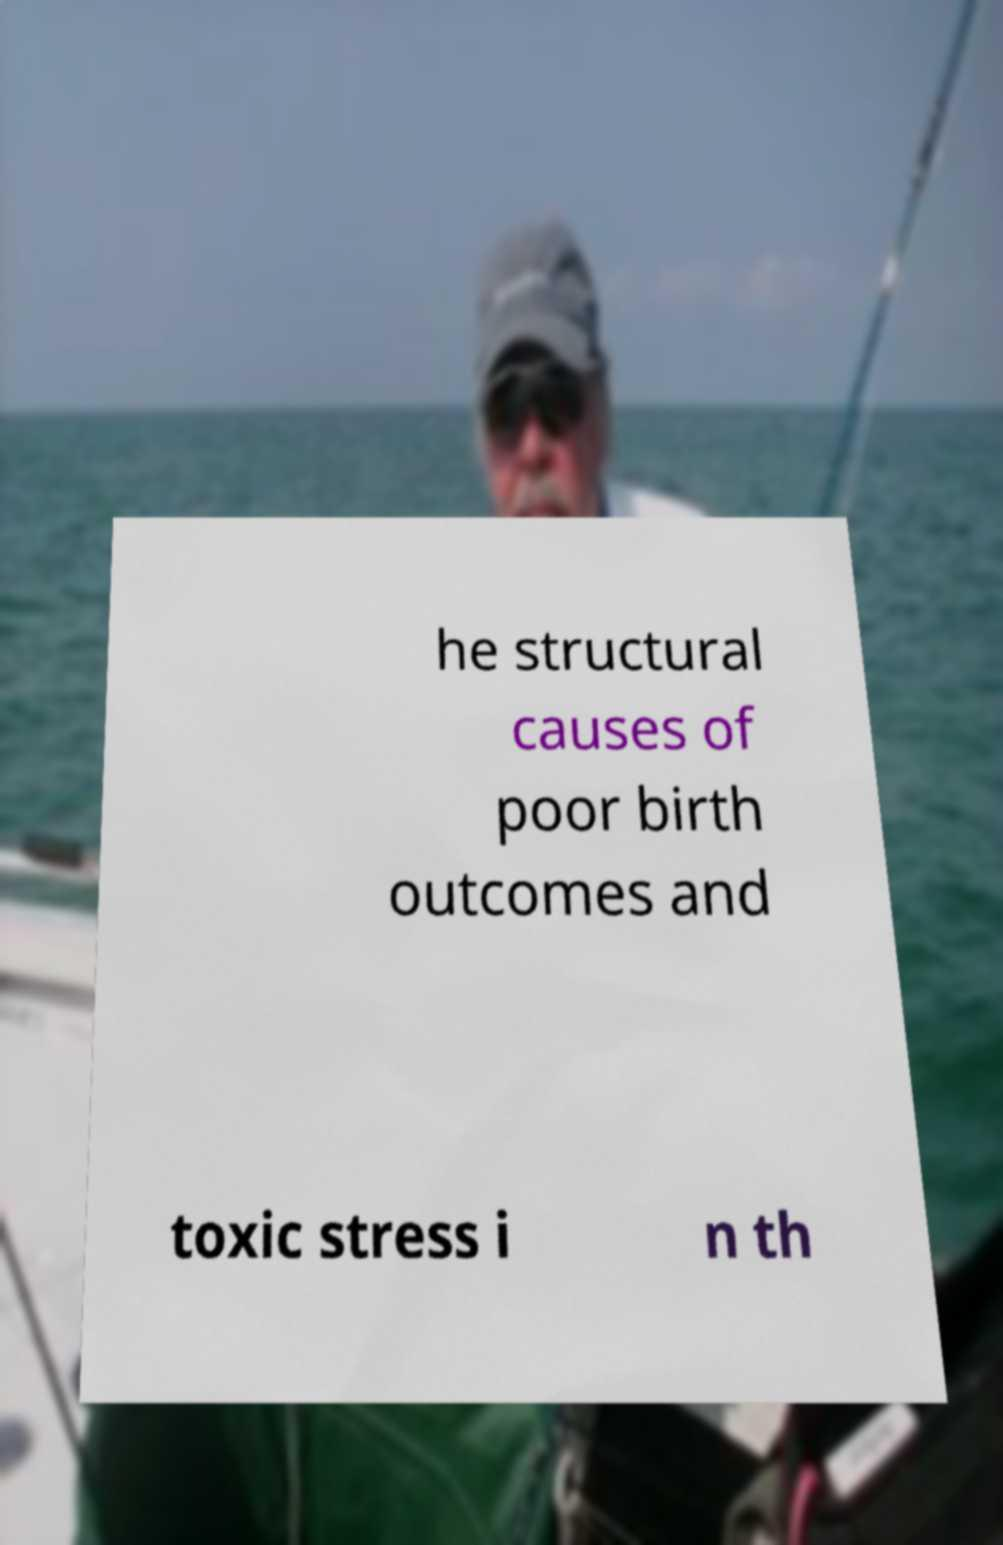I need the written content from this picture converted into text. Can you do that? he structural causes of poor birth outcomes and toxic stress i n th 